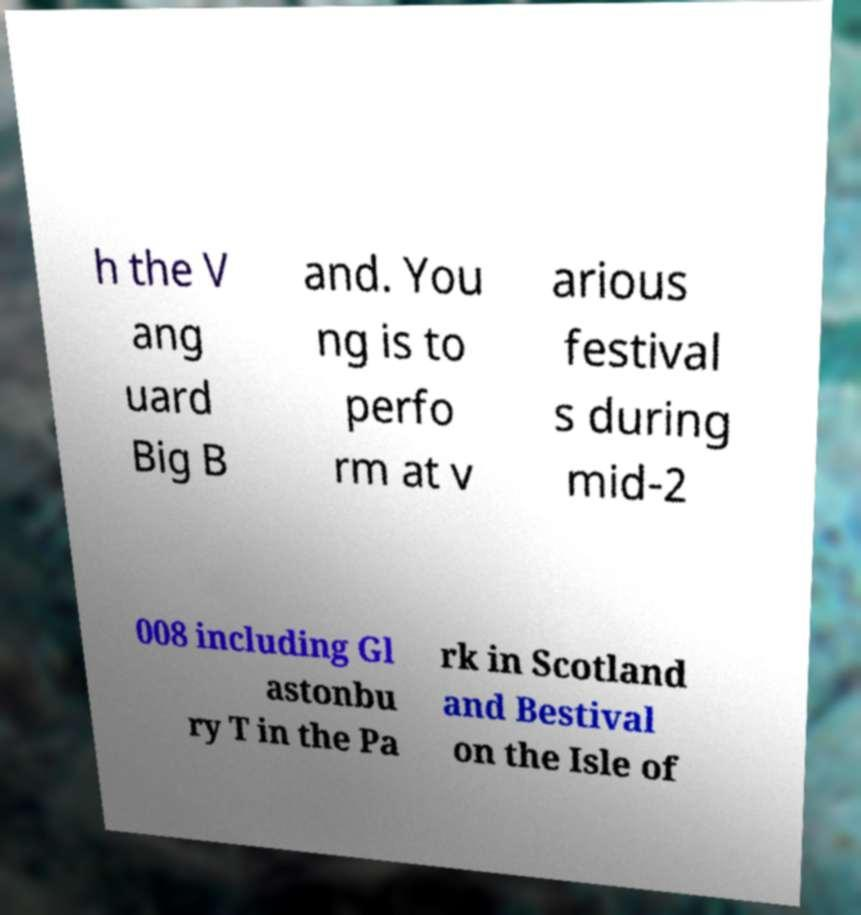What messages or text are displayed in this image? I need them in a readable, typed format. h the V ang uard Big B and. You ng is to perfo rm at v arious festival s during mid-2 008 including Gl astonbu ry T in the Pa rk in Scotland and Bestival on the Isle of 